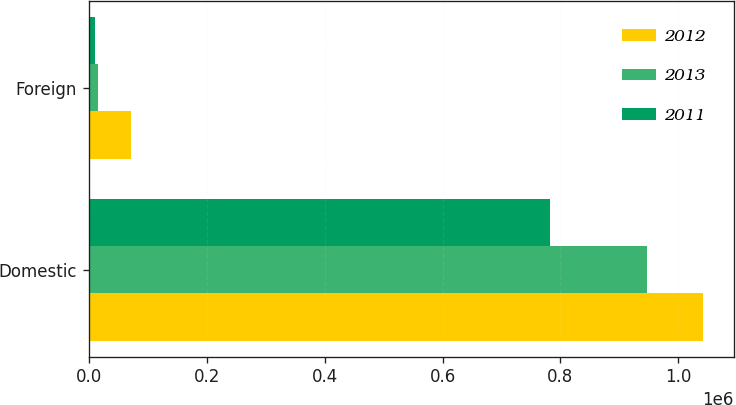Convert chart to OTSL. <chart><loc_0><loc_0><loc_500><loc_500><stacked_bar_chart><ecel><fcel>Domestic<fcel>Foreign<nl><fcel>2012<fcel>1.04232e+06<fcel>71988<nl><fcel>2013<fcel>946592<fcel>14920<nl><fcel>2011<fcel>782896<fcel>9768<nl></chart> 